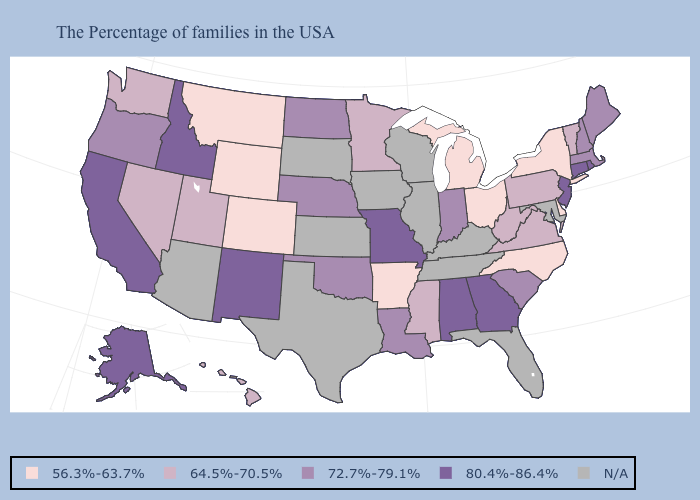Name the states that have a value in the range 72.7%-79.1%?
Keep it brief. Maine, Massachusetts, New Hampshire, South Carolina, Indiana, Louisiana, Nebraska, Oklahoma, North Dakota, Oregon. What is the value of Vermont?
Be succinct. 64.5%-70.5%. What is the lowest value in the MidWest?
Concise answer only. 56.3%-63.7%. Does the first symbol in the legend represent the smallest category?
Short answer required. Yes. Name the states that have a value in the range 72.7%-79.1%?
Be succinct. Maine, Massachusetts, New Hampshire, South Carolina, Indiana, Louisiana, Nebraska, Oklahoma, North Dakota, Oregon. Is the legend a continuous bar?
Answer briefly. No. What is the value of Rhode Island?
Short answer required. 80.4%-86.4%. Which states have the highest value in the USA?
Keep it brief. Rhode Island, Connecticut, New Jersey, Georgia, Alabama, Missouri, New Mexico, Idaho, California, Alaska. Name the states that have a value in the range 56.3%-63.7%?
Answer briefly. New York, Delaware, North Carolina, Ohio, Michigan, Arkansas, Wyoming, Colorado, Montana. Name the states that have a value in the range 56.3%-63.7%?
Give a very brief answer. New York, Delaware, North Carolina, Ohio, Michigan, Arkansas, Wyoming, Colorado, Montana. What is the lowest value in the USA?
Concise answer only. 56.3%-63.7%. What is the value of Alabama?
Short answer required. 80.4%-86.4%. What is the lowest value in the USA?
Be succinct. 56.3%-63.7%. Is the legend a continuous bar?
Be succinct. No. Does the first symbol in the legend represent the smallest category?
Short answer required. Yes. 